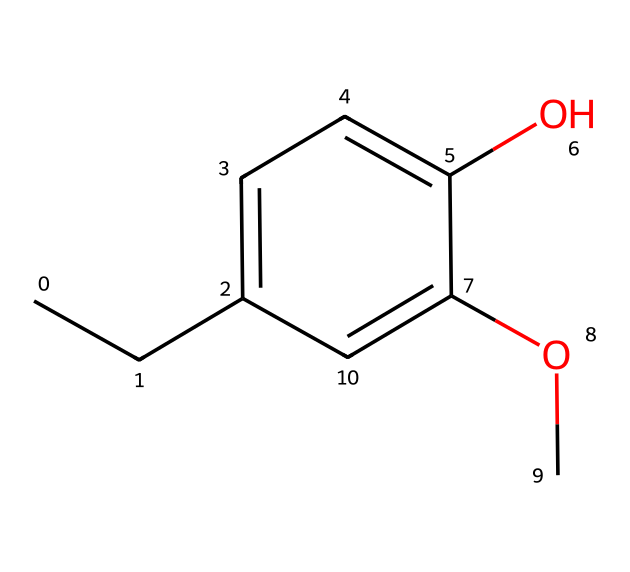What is the total number of carbon atoms in eugenol? By examining the structural formula and counting the carbon (C) symbols, we see there are 10 carbon atoms present in the molecule.
Answer: 10 How many hydroxyl groups are present in eugenol? The presence of the -OH group in the structure indicates one hydroxyl group attached to the aromatic ring.
Answer: 1 What is the primary functional group in eugenol? The -OH (hydroxyl) group is the primary functional group; it defines the compound as a phenol.
Answer: hydroxyl How many double bonds are present in eugenol? By counting the double bonds in the aromatic ring and the C=C bond in the side chain, there are 3 double bonds total in eugenol's structure.
Answer: 3 What type of compound is eugenol classified as? Given the presence of the hydroxyl group and the aromatic ring, eugenol is classified as a phenolic compound.
Answer: phenolic Which atoms are most abundant in eugenol? By analyzing the entire structure, we see that carbon (C) and hydrogen (H) atoms are the most abundant, with carbon being more prevalent in the structure.
Answer: carbon and hydrogen Is eugenol likely to be soluble in water? The presence of the hydroxyl group suggests that eugenol can interact with water due to hydrogen bonding, indicating it is likely to be soluble.
Answer: likely 